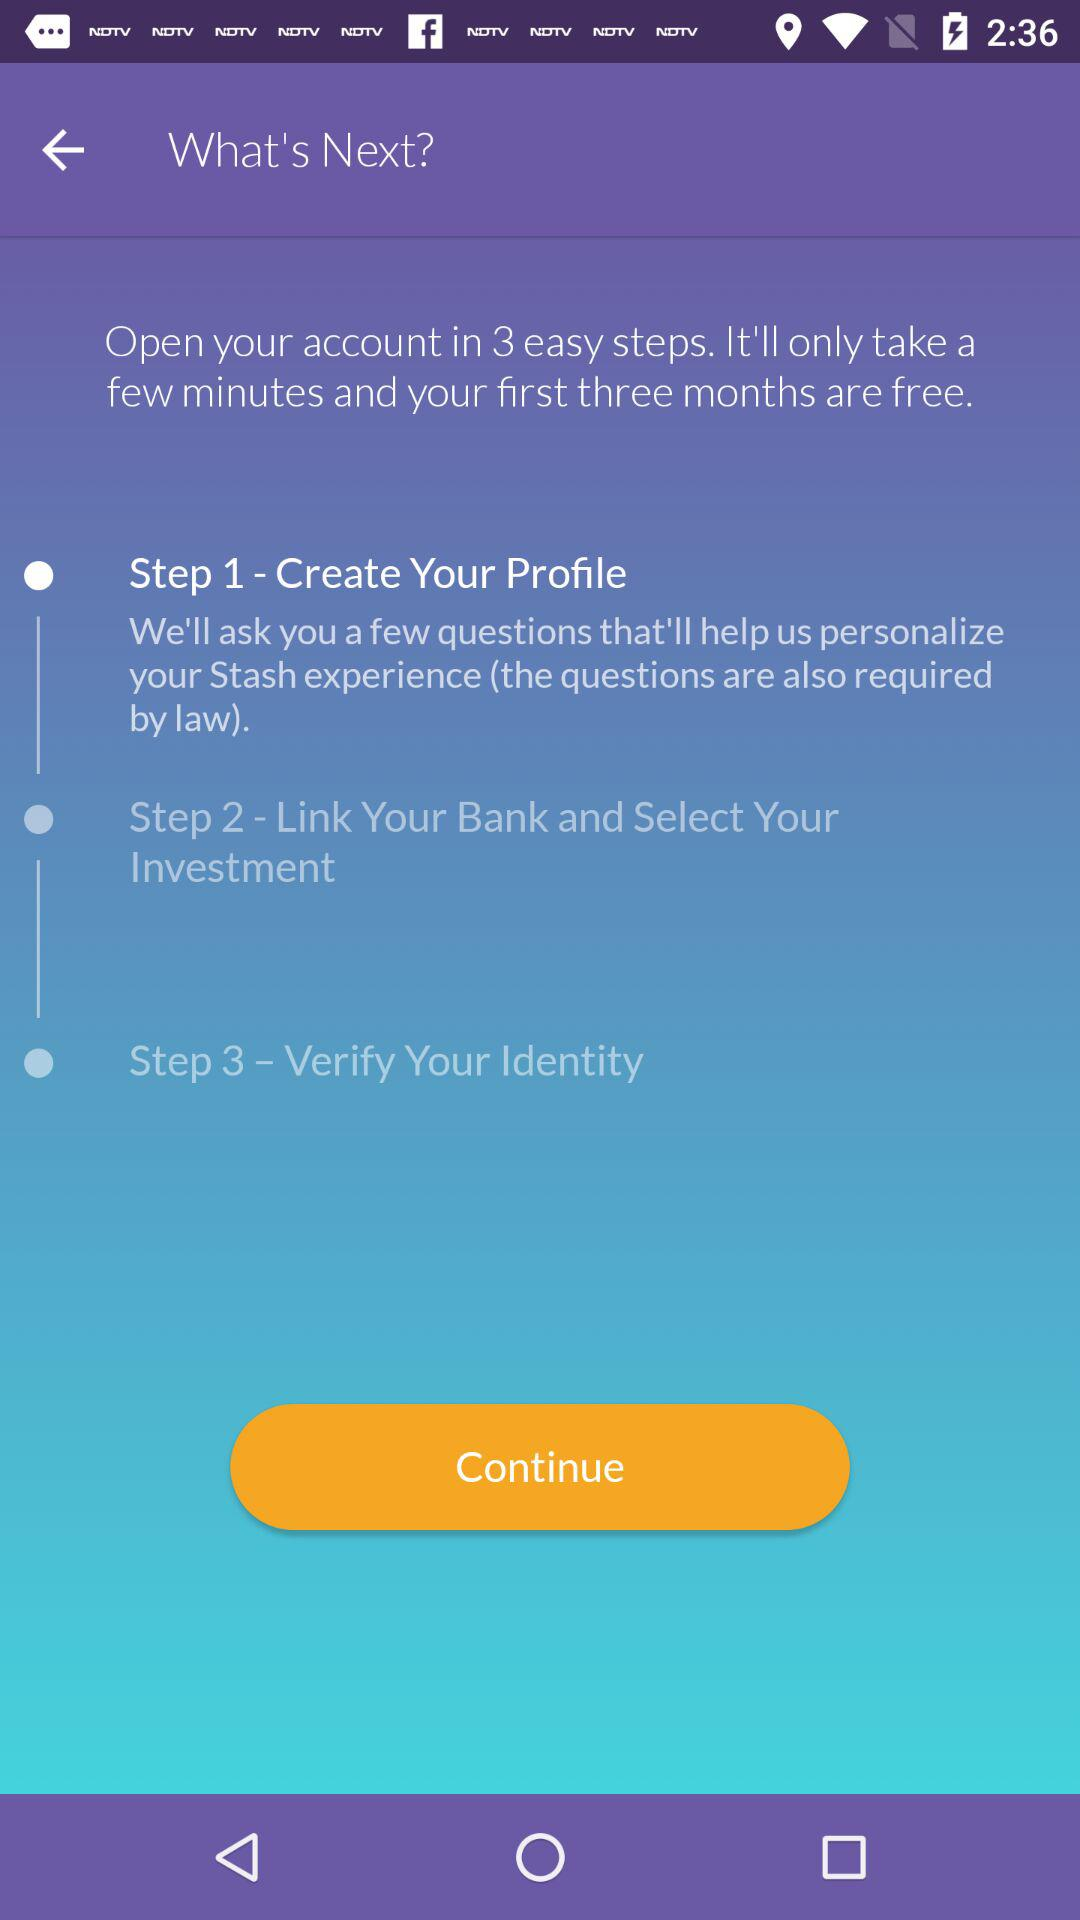What is the second step for opening the account? The second step for opening the account is "Link Your Bank and Select Your Investment". 